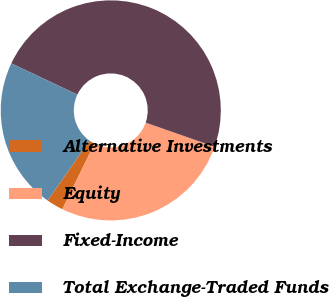Convert chart to OTSL. <chart><loc_0><loc_0><loc_500><loc_500><pie_chart><fcel>Alternative Investments<fcel>Equity<fcel>Fixed-Income<fcel>Total Exchange-Traded Funds<nl><fcel>2.48%<fcel>26.89%<fcel>48.33%<fcel>22.3%<nl></chart> 